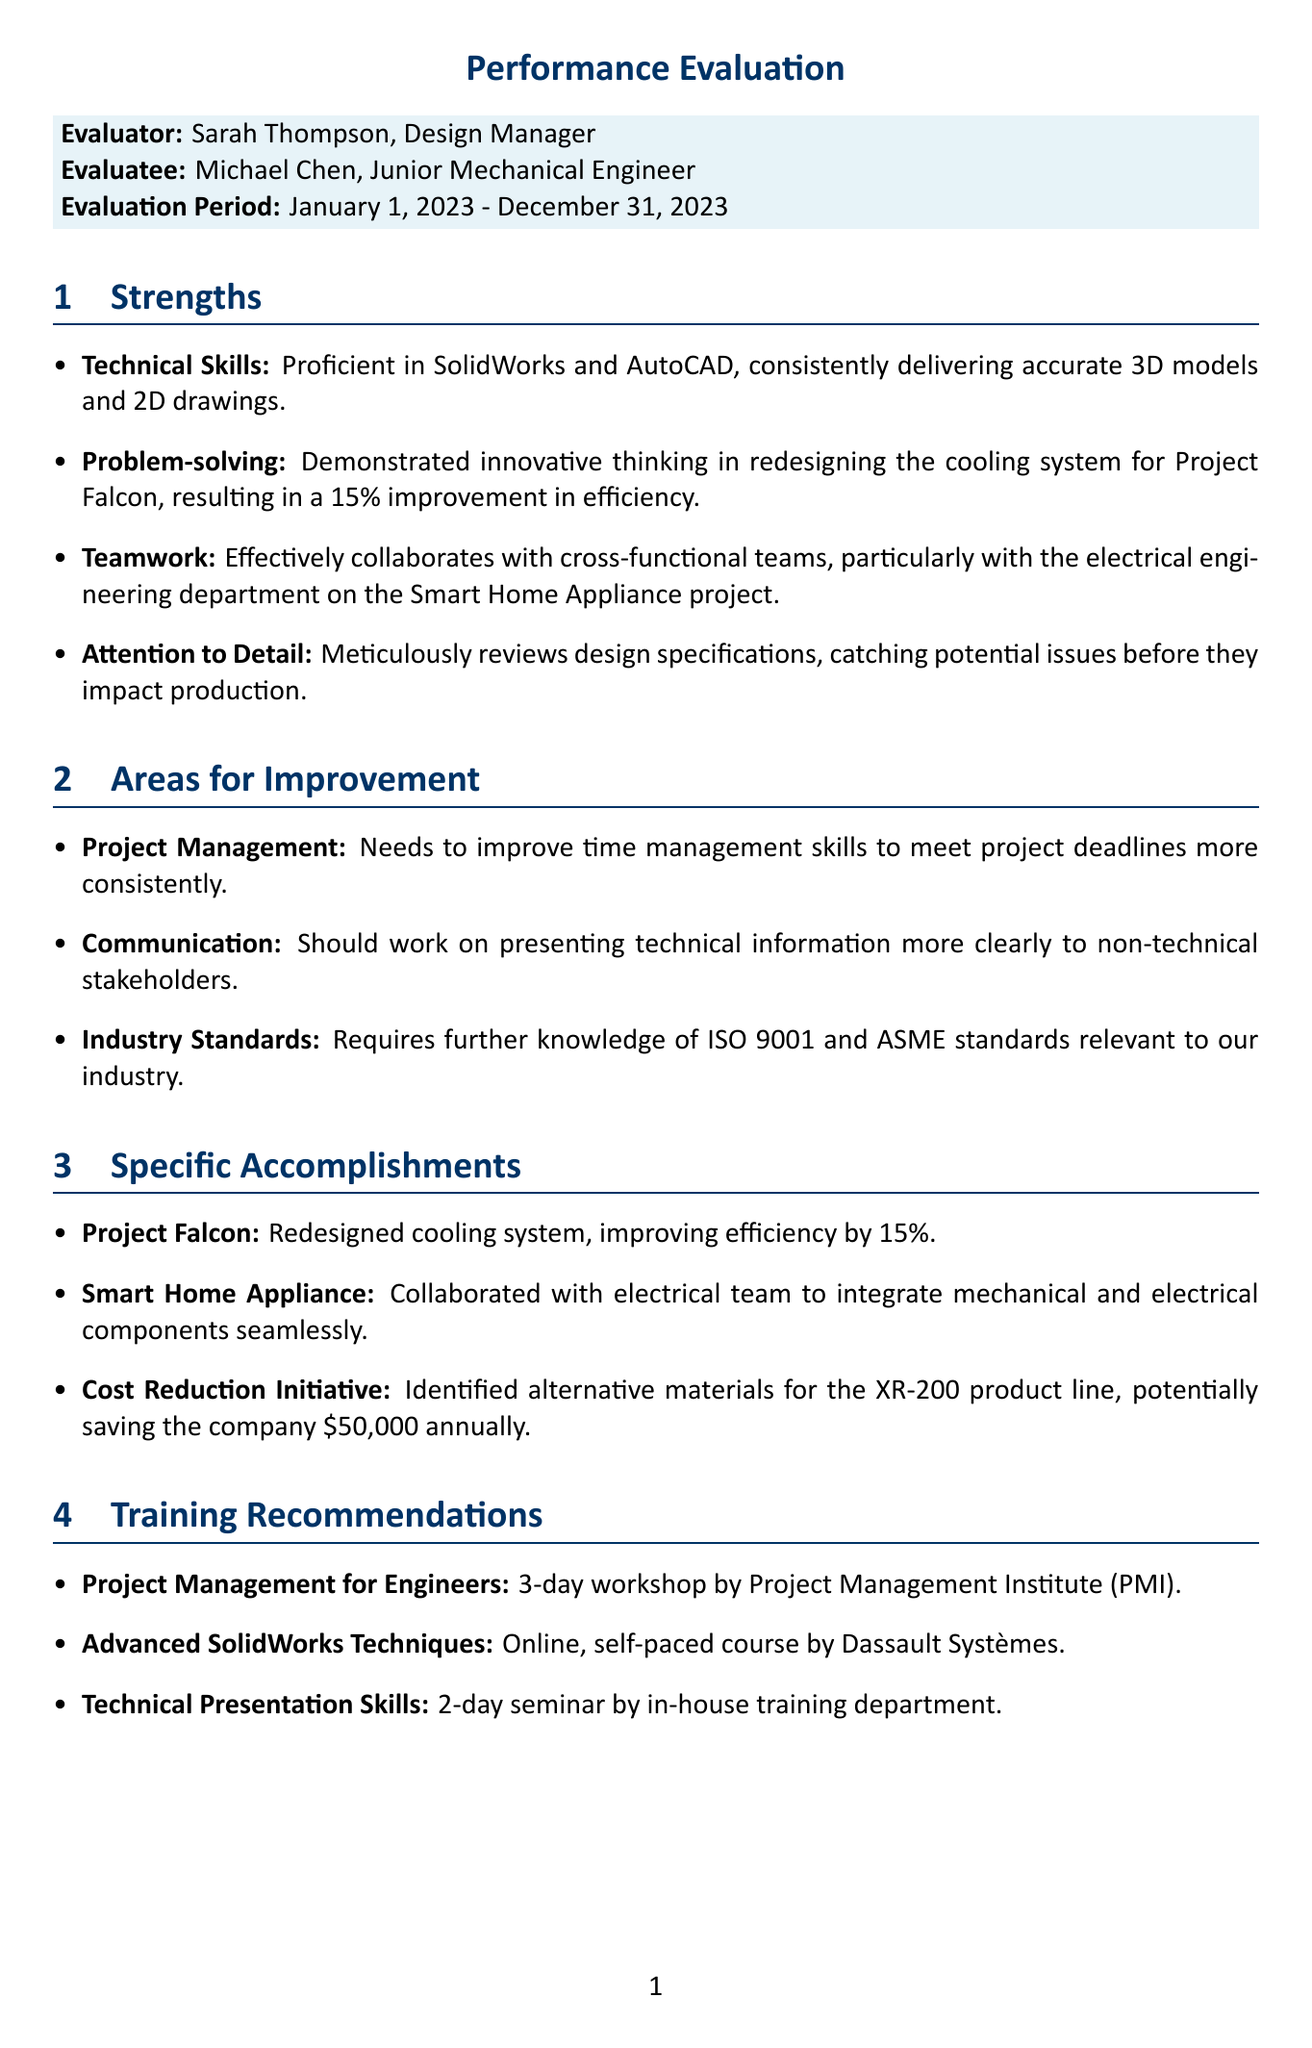What is the name of the evaluator? The evaluator's name is mentioned in the document as Sarah Thompson, who is the Design Manager.
Answer: Sarah Thompson What project did Michael improve with a 15% efficiency increase? The document states that Michael redesigned the cooling system for Project Falcon, resulting in improved efficiency.
Answer: Project Falcon What course is recommended for improving project management skills? The document lists one of the training recommendations as "Project Management for Engineers" by the Project Management Institute.
Answer: Project Management for Engineers What are Michael's two areas for improvement? The document specifies three areas for improvement, but looks for two: Project Management and Communication.
Answer: Project Management, Communication What significant cost reduction did Michael identify? The document states that Michael identified alternative materials for the XR-200 product line, potentially leading to significant savings.
Answer: $50,000 What goal is assigned to Michael for the upcoming XR-300 product development? The document highlights Michael's goal to lead a small team on an upcoming project, specifically mentioning the XR-300 product development.
Answer: Lead a small team During what period was the evaluation conducted? The document clearly indicates the evaluation period for Michael Chen's performance evaluation as January 1, 2023 - December 31, 2023.
Answer: January 1, 2023 - December 31, 2023 Which course involves technical presentation skills training? The document mentions "Technical Presentation Skills" as a recommended course to enhance presentation abilities.
Answer: Technical Presentation Skills What department did Michael effectively collaborate with on the Smart Home Appliance project? The document mentions that Michael effectively collaborates with the electrical engineering department on the project.
Answer: Electrical engineering department 